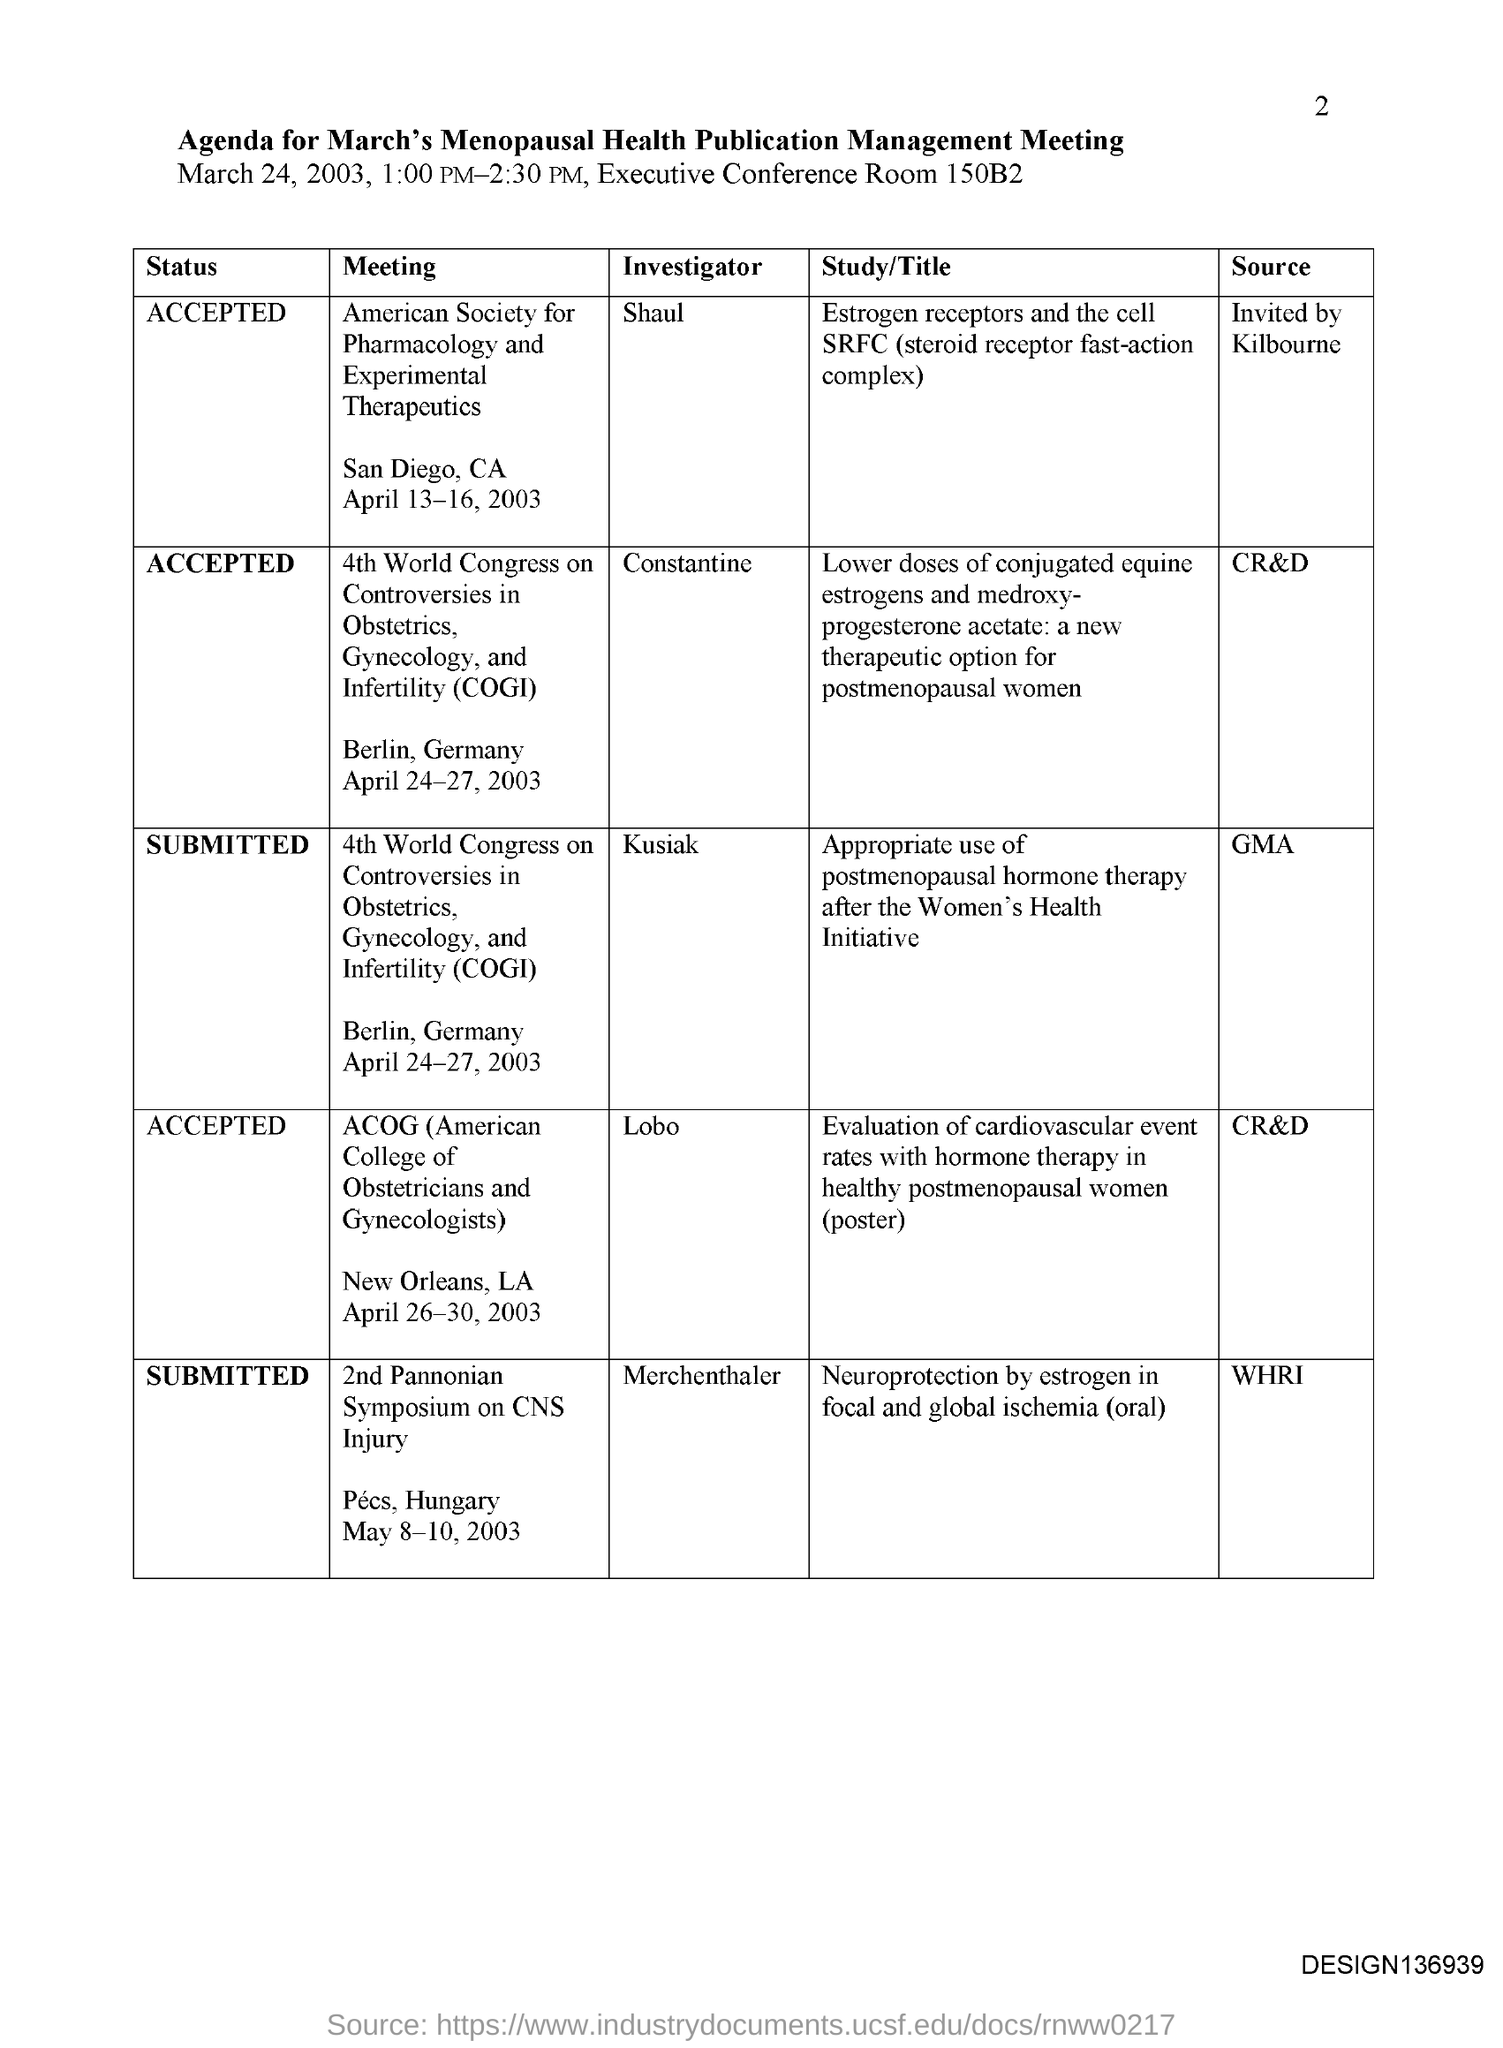Who is the Investigator/Author for American society for pharmacology and experimental therapeutics meeting?
Your answer should be compact. Shaul. Where is the American society for pharmacology and experimental therapeutics meeting held?
Ensure brevity in your answer.  San Diego, CA. When is the American society for pharmacology and experimental therapeutics meeting held?
Offer a very short reply. April 13-16, 2003. Who is the Investigator/Author for ACOG Meeting?
Give a very brief answer. Lobo. Where is the for ACOG Meeting held?
Your response must be concise. New Orleans, LA. When is the for ACOG Meeting held?
Keep it short and to the point. April 26-30, 2003. 